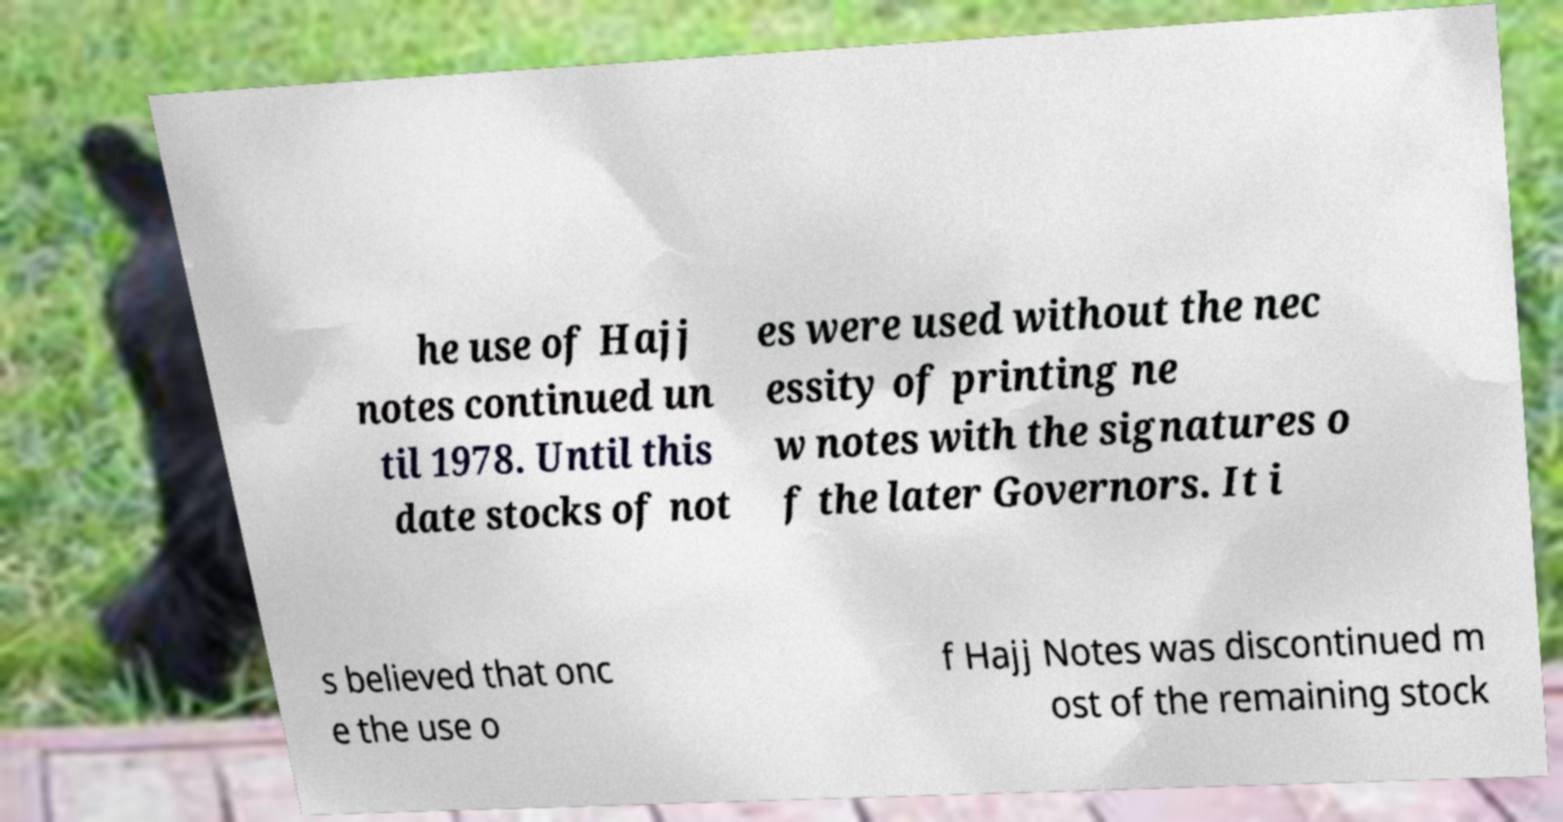Can you read and provide the text displayed in the image?This photo seems to have some interesting text. Can you extract and type it out for me? he use of Hajj notes continued un til 1978. Until this date stocks of not es were used without the nec essity of printing ne w notes with the signatures o f the later Governors. It i s believed that onc e the use o f Hajj Notes was discontinued m ost of the remaining stock 